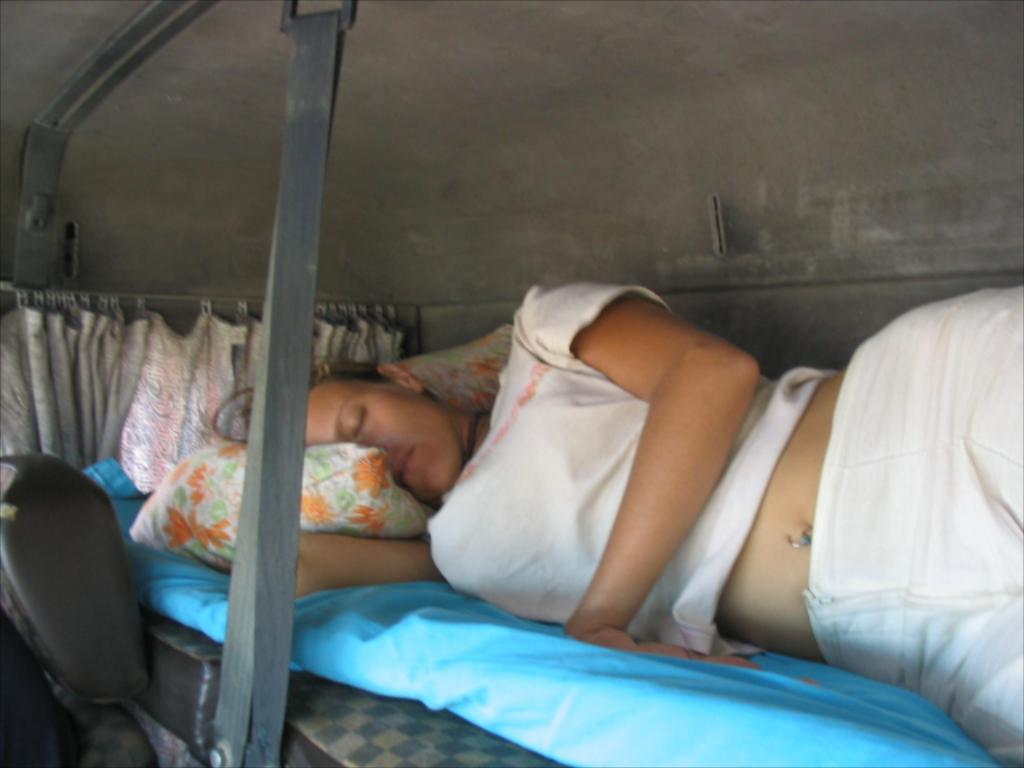Who is present in the image? There is a person in the image. What is the person wearing? The person is wearing a white t-shirt. What is the person's position in the image? The person is lying on a bed. What can be seen behind the person? There is a curtain behind the person. What type of farm animals can be seen flocking around the person in the image? There are no farm animals present in the image. 